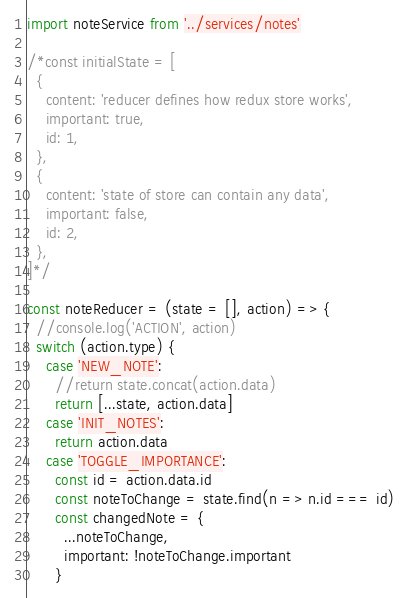Convert code to text. <code><loc_0><loc_0><loc_500><loc_500><_JavaScript_>import noteService from '../services/notes'

/*const initialState = [
  {
    content: 'reducer defines how redux store works',
    important: true,
    id: 1,
  },
  {
    content: 'state of store can contain any data',
    important: false,
    id: 2,
  },
]*/

const noteReducer = (state = [], action) => {
  //console.log('ACTION', action)
  switch (action.type) {
    case 'NEW_NOTE':
      //return state.concat(action.data)
      return [...state, action.data]
    case 'INIT_NOTES':
      return action.data
    case 'TOGGLE_IMPORTANCE':
      const id = action.data.id
      const noteToChange = state.find(n => n.id === id)
      const changedNote = {
        ...noteToChange,
        important: !noteToChange.important
      }</code> 